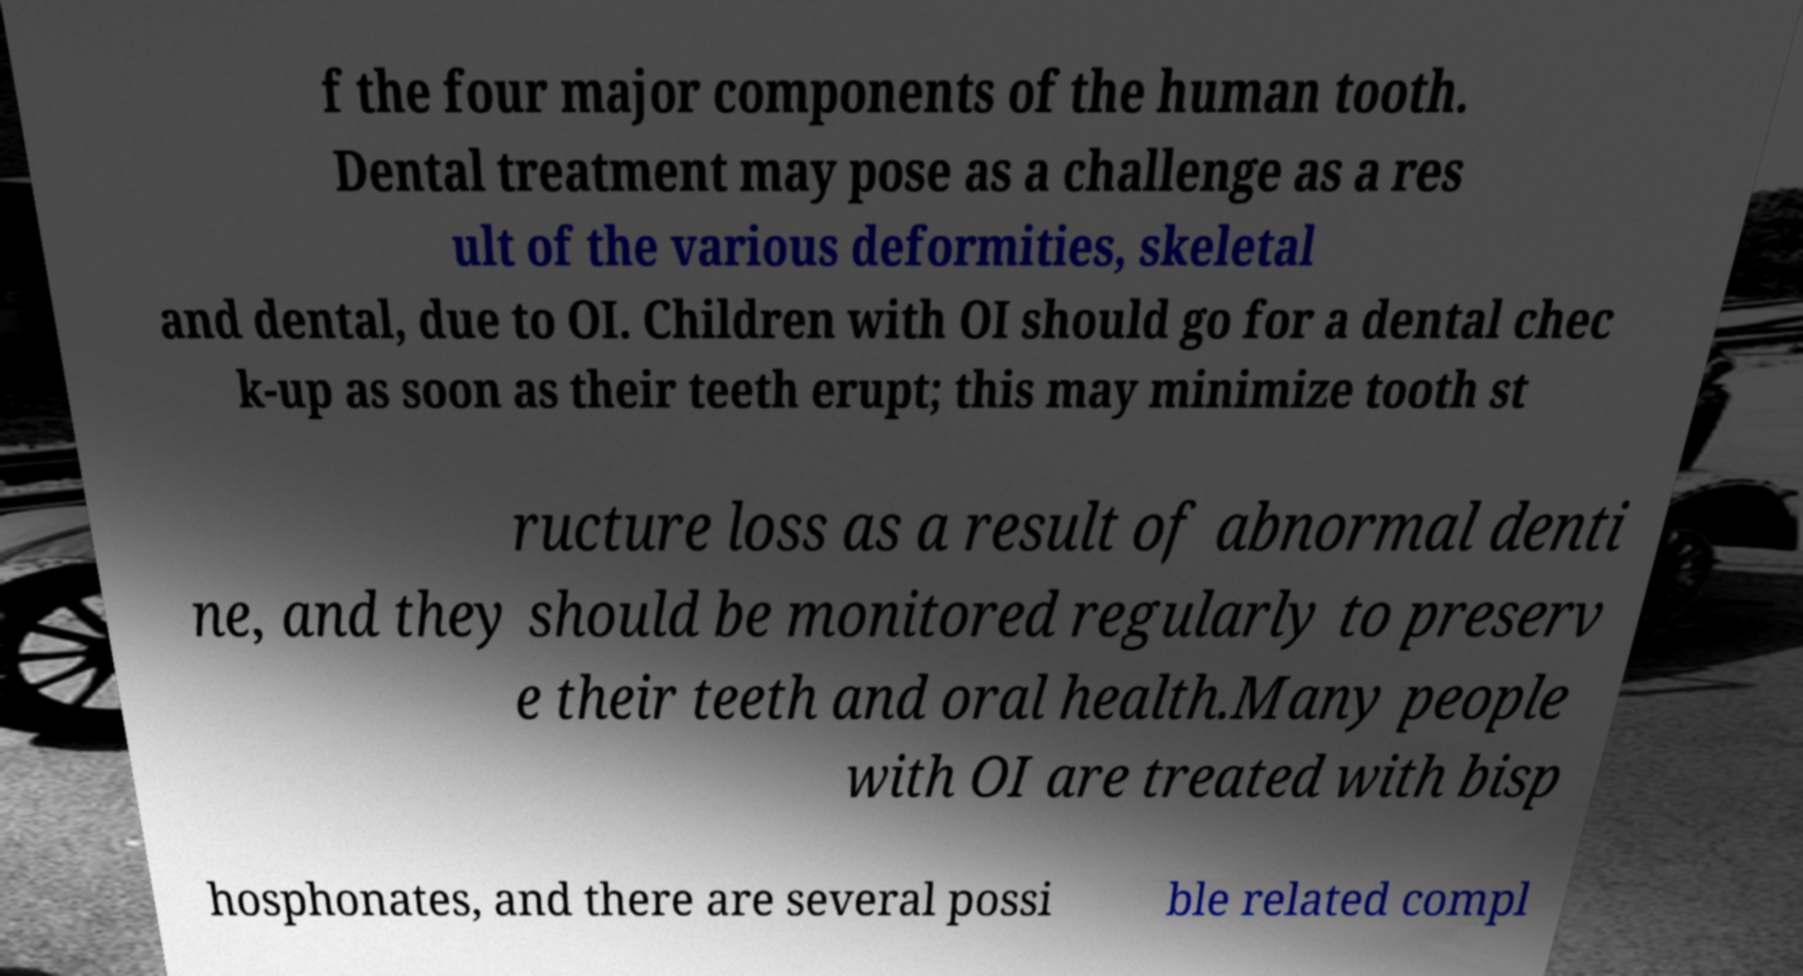There's text embedded in this image that I need extracted. Can you transcribe it verbatim? f the four major components of the human tooth. Dental treatment may pose as a challenge as a res ult of the various deformities, skeletal and dental, due to OI. Children with OI should go for a dental chec k-up as soon as their teeth erupt; this may minimize tooth st ructure loss as a result of abnormal denti ne, and they should be monitored regularly to preserv e their teeth and oral health.Many people with OI are treated with bisp hosphonates, and there are several possi ble related compl 